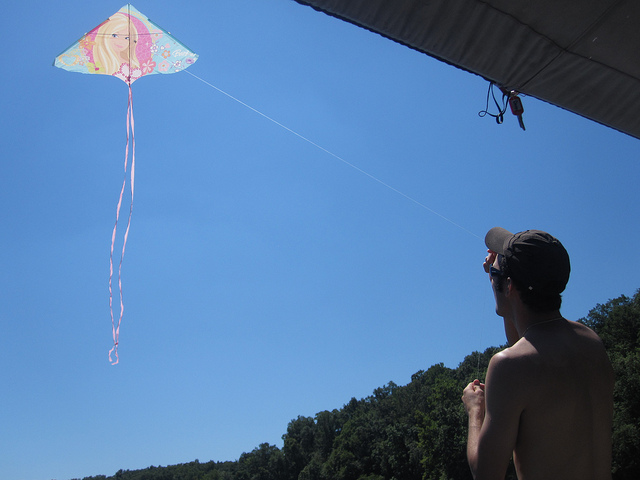How many kites are in the sky? There is one kite flying in the sky, beautifully decorated with a mix of bright and pastel colors, tethered by a thin string that reflects the carefree spirit of kite-flying on a clear day. 